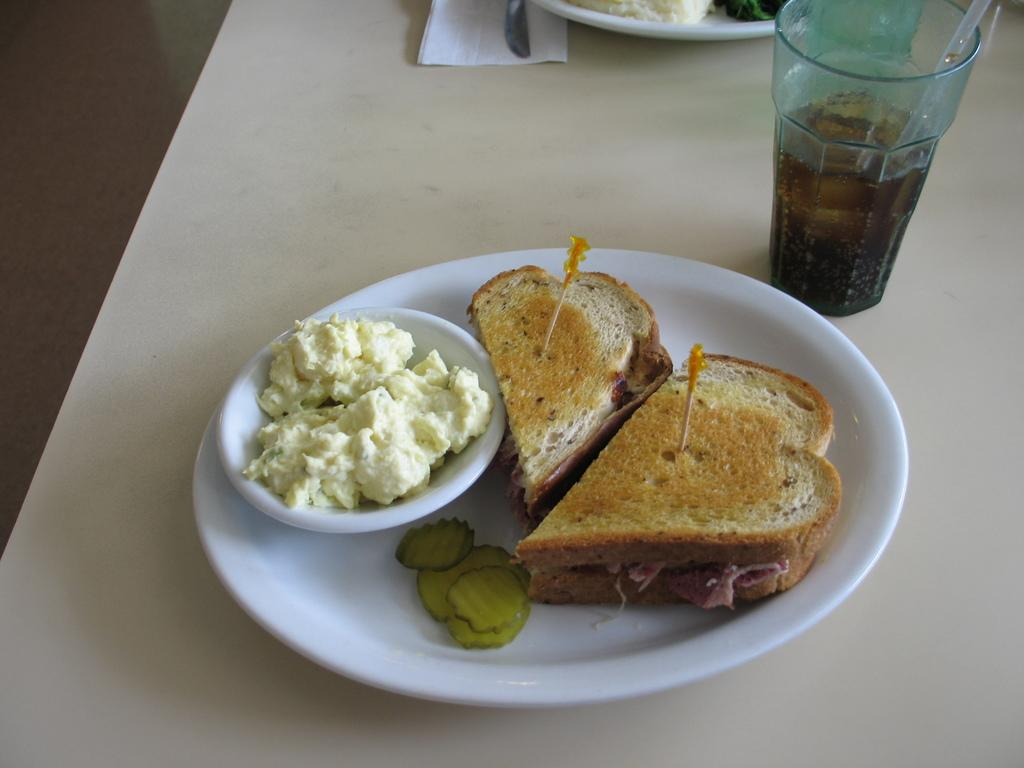What type of objects can be seen in the image? There are food items, a bowl, a glass, a knife, and a plate in the image. How is the bowl positioned in relation to the plate? The bowl is on a plate in the image. What might be used for drinking in the image? There is a glass on the table in the image. What item can be used for cutting in the image? There is a knife in the image. What object might be used for serving food in the image? A: There is a plate in the image. What can be used for cleaning or wiping in the image? There is a tissue paper in the image. Reasoning: Let's think step by step by step in order to produce the conversation. We start by identifying the main objects in the image, which include food items, a bowl, a glass, a knife, and a plate. Then, we describe the relationships between these objects, such as the bowl being on a plate. We also mention the presence of a tissue paper, which can be used for cleaning or wiping. Each question is designed to elicit a specific detail about the image that is known from the provided facts provided. Absurd Question/Answer: How many children are playing with a card in the image? There are no children or cards present in the image. What type of currency is visible in the image? There is no currency visible in the image. How many children are playing with a card in the image? There are no children or cards present in the image. What type of currency is visible in the image? There is no currency visible in the image. 